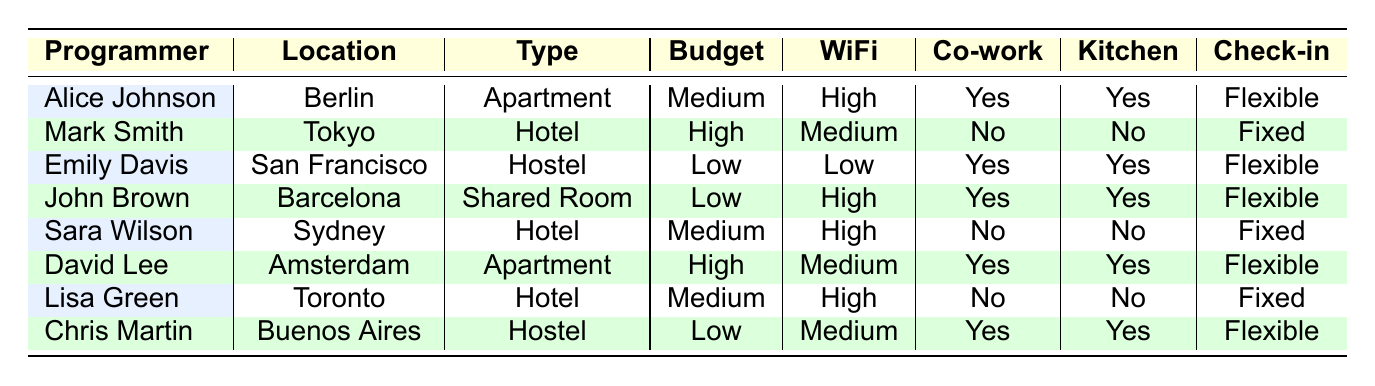What accommodation type does Alice Johnson prefer? Alice Johnson's preferred accommodation type is listed under the "Type" column in her row, which states "Apartment."
Answer: Apartment Which locations offer kitchen access for programmers? To identify locations with kitchen access, we can look at the "Kitchen" column in each row. The rows for Alice Johnson, Emily Davis, John Brown, David Lee, and Chris Martin indicate "Yes" for kitchen access. Their locations are Berlin, San Francisco, Barcelona, Amsterdam, and Buenos Aires, respectively.
Answer: Berlin, San Francisco, Barcelona, Amsterdam, Buenos Aires Is there any programmer who prefers a hostel? By checking the table, the entries for Emily Davis and Chris Martin indicate that they both prefer a hostel, as indicated in the "Type" column.
Answer: Yes How many programmers have a flexible check-in time? We can count the "Flexible" entries in the "Check-in" column. The programmers with a flexible check-in are Alice Johnson, Emily Davis, John Brown, David Lee, and Chris Martin, totaling 5 programmers.
Answer: 5 What is the average budget tier of programmers? We classify the budget tiers as Low=1, Medium=2, High=3. Counting each tier gives: Low (3), Medium (3), and High (2). The computation is (1*3 + 2*3 + 3*2) / 8 = (3 + 6 + 6) / 8 = 15 / 8, which simplifies to 1.875. The average budget tier is approximately 1.88 (when considering tiers Low, Medium, and High).
Answer: 1.88 